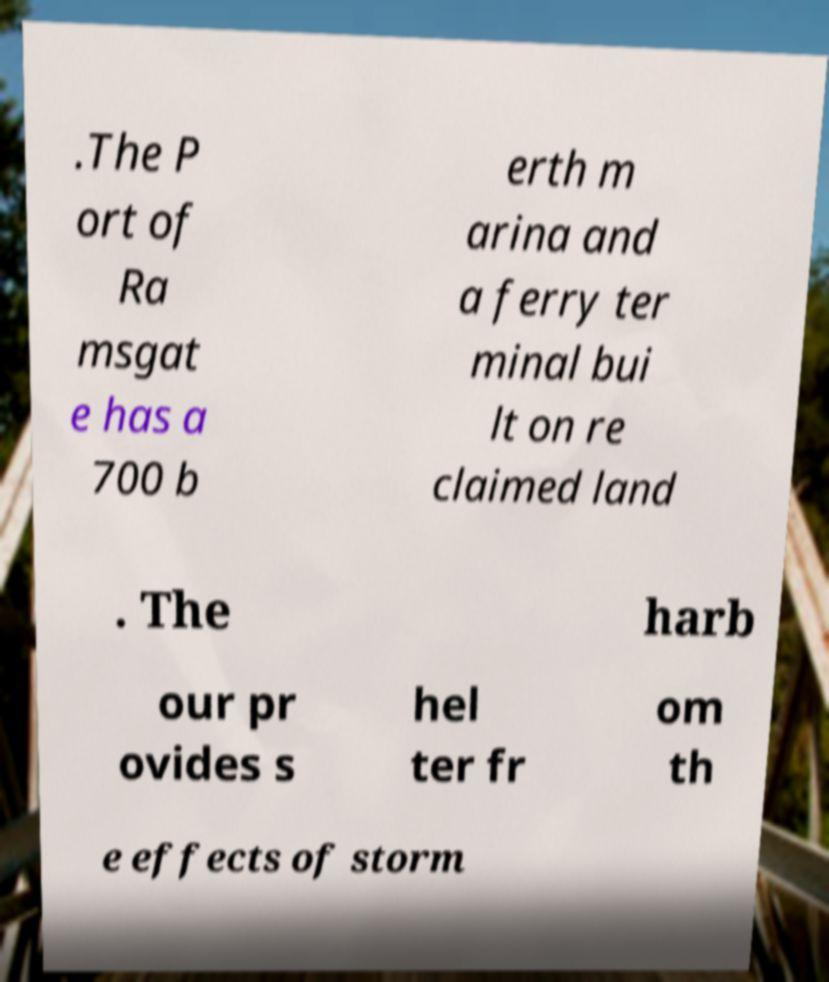Can you accurately transcribe the text from the provided image for me? .The P ort of Ra msgat e has a 700 b erth m arina and a ferry ter minal bui lt on re claimed land . The harb our pr ovides s hel ter fr om th e effects of storm 